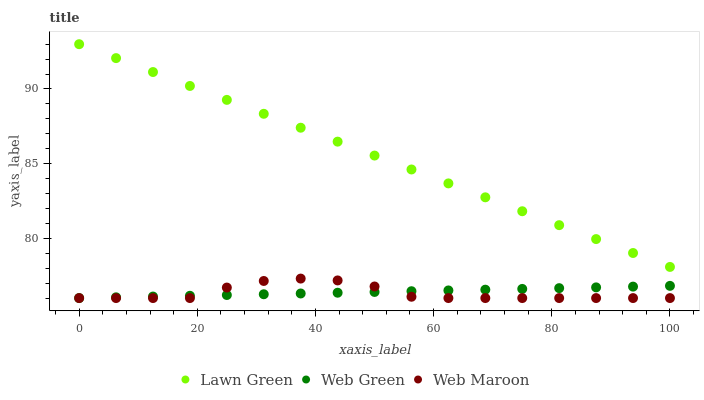Does Web Maroon have the minimum area under the curve?
Answer yes or no. Yes. Does Lawn Green have the maximum area under the curve?
Answer yes or no. Yes. Does Web Green have the minimum area under the curve?
Answer yes or no. No. Does Web Green have the maximum area under the curve?
Answer yes or no. No. Is Web Green the smoothest?
Answer yes or no. Yes. Is Web Maroon the roughest?
Answer yes or no. Yes. Is Web Maroon the smoothest?
Answer yes or no. No. Is Web Green the roughest?
Answer yes or no. No. Does Web Maroon have the lowest value?
Answer yes or no. Yes. Does Lawn Green have the highest value?
Answer yes or no. Yes. Does Web Maroon have the highest value?
Answer yes or no. No. Is Web Maroon less than Lawn Green?
Answer yes or no. Yes. Is Lawn Green greater than Web Maroon?
Answer yes or no. Yes. Does Web Maroon intersect Web Green?
Answer yes or no. Yes. Is Web Maroon less than Web Green?
Answer yes or no. No. Is Web Maroon greater than Web Green?
Answer yes or no. No. Does Web Maroon intersect Lawn Green?
Answer yes or no. No. 